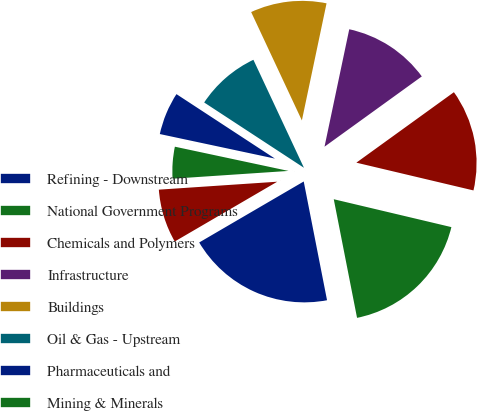Convert chart. <chart><loc_0><loc_0><loc_500><loc_500><pie_chart><fcel>Refining - Downstream<fcel>National Government Programs<fcel>Chemicals and Polymers<fcel>Infrastructure<fcel>Buildings<fcel>Oil & Gas - Upstream<fcel>Pharmaceuticals and<fcel>Mining & Minerals<fcel>Industrial and Other<nl><fcel>19.68%<fcel>18.21%<fcel>13.66%<fcel>11.74%<fcel>10.27%<fcel>8.81%<fcel>5.88%<fcel>4.41%<fcel>7.34%<nl></chart> 